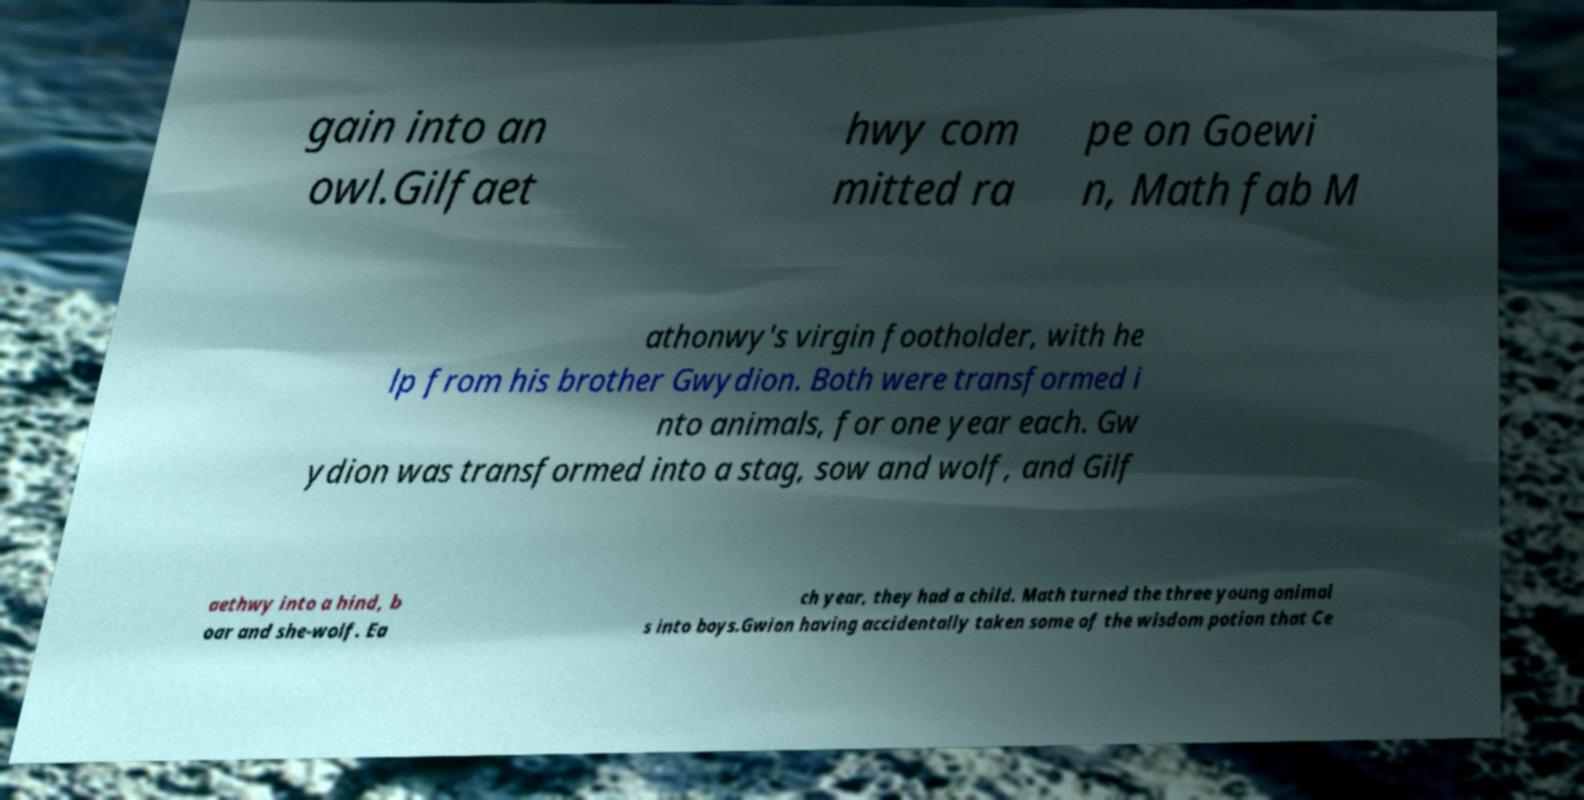Can you read and provide the text displayed in the image?This photo seems to have some interesting text. Can you extract and type it out for me? gain into an owl.Gilfaet hwy com mitted ra pe on Goewi n, Math fab M athonwy's virgin footholder, with he lp from his brother Gwydion. Both were transformed i nto animals, for one year each. Gw ydion was transformed into a stag, sow and wolf, and Gilf aethwy into a hind, b oar and she-wolf. Ea ch year, they had a child. Math turned the three young animal s into boys.Gwion having accidentally taken some of the wisdom potion that Ce 